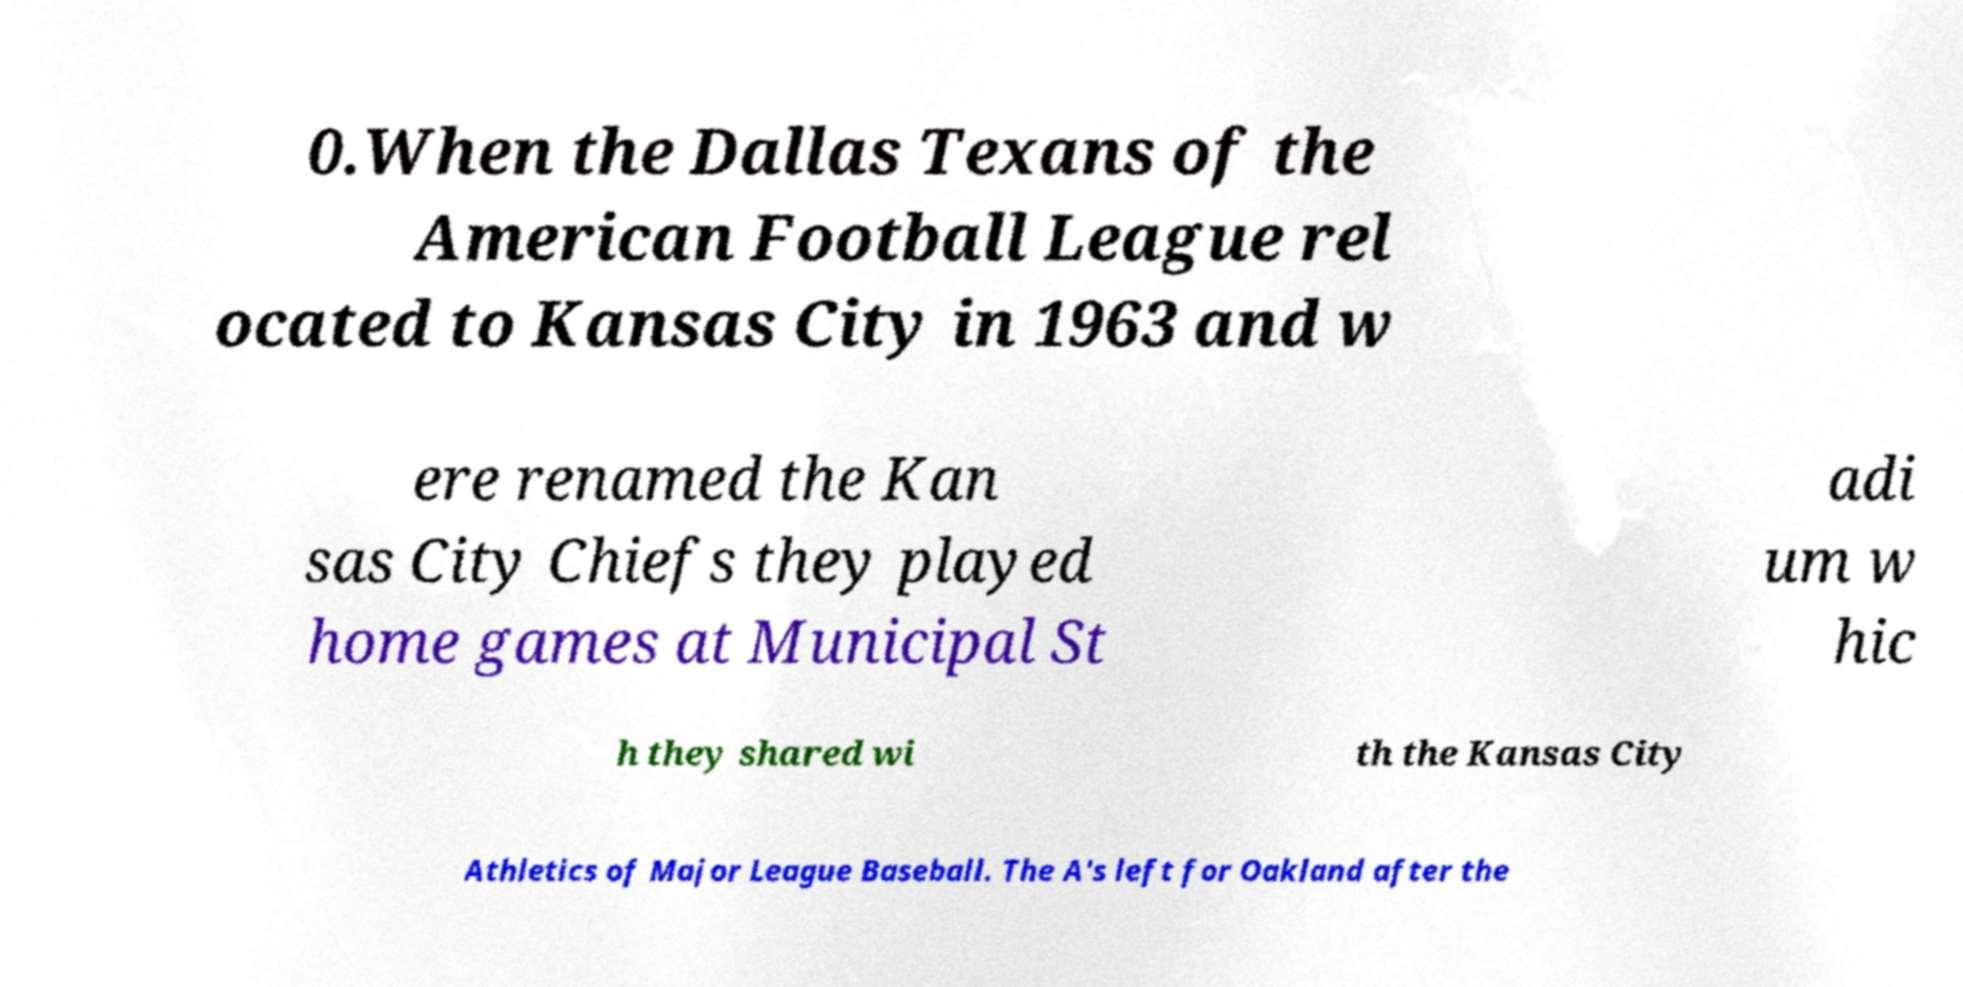I need the written content from this picture converted into text. Can you do that? 0.When the Dallas Texans of the American Football League rel ocated to Kansas City in 1963 and w ere renamed the Kan sas City Chiefs they played home games at Municipal St adi um w hic h they shared wi th the Kansas City Athletics of Major League Baseball. The A's left for Oakland after the 